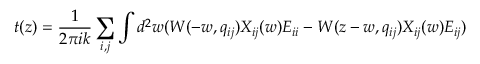<formula> <loc_0><loc_0><loc_500><loc_500>t ( z ) = \frac { 1 } 2 \pi i k } \sum _ { i , j } \int d ^ { 2 } w ( W ( - w , q _ { i j } ) X _ { i j } ( w ) E _ { i i } - W ( z - w , q _ { i j } ) X _ { i j } ( w ) E _ { i j } )</formula> 